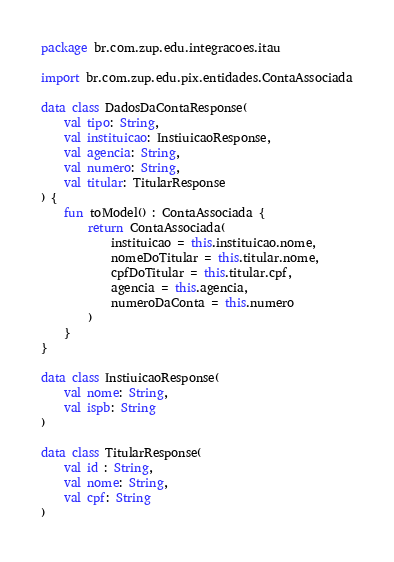Convert code to text. <code><loc_0><loc_0><loc_500><loc_500><_Kotlin_>package br.com.zup.edu.integracoes.itau

import br.com.zup.edu.pix.entidades.ContaAssociada

data class DadosDaContaResponse(
    val tipo: String,
    val instituicao: InstiuicaoResponse,
    val agencia: String,
    val numero: String,
    val titular: TitularResponse
) {
    fun toModel() : ContaAssociada {
        return ContaAssociada(
            instituicao = this.instituicao.nome,
            nomeDoTitular = this.titular.nome,
            cpfDoTitular = this.titular.cpf,
            agencia = this.agencia,
            numeroDaConta = this.numero
        )
    }
}

data class InstiuicaoResponse(
    val nome: String,
    val ispb: String
)

data class TitularResponse(
    val id : String,
    val nome: String,
    val cpf: String
)</code> 